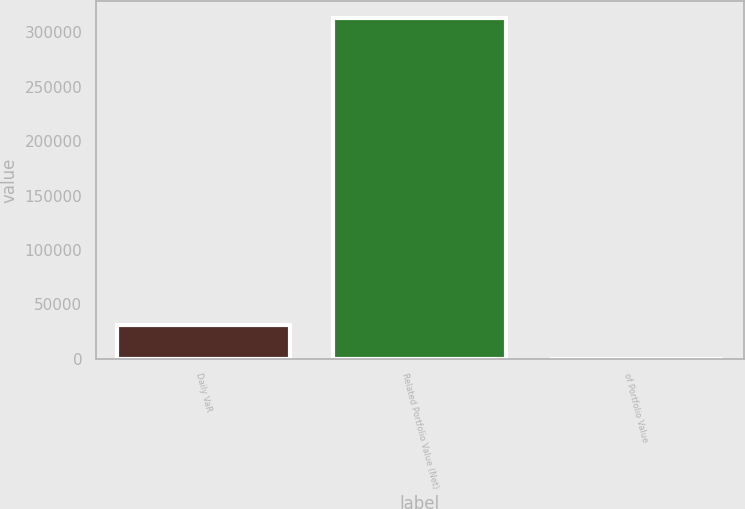Convert chart to OTSL. <chart><loc_0><loc_0><loc_500><loc_500><bar_chart><fcel>Daily VaR<fcel>Related Portfolio Value (Net)<fcel>of Portfolio Value<nl><fcel>31291.8<fcel>312917<fcel>0.15<nl></chart> 